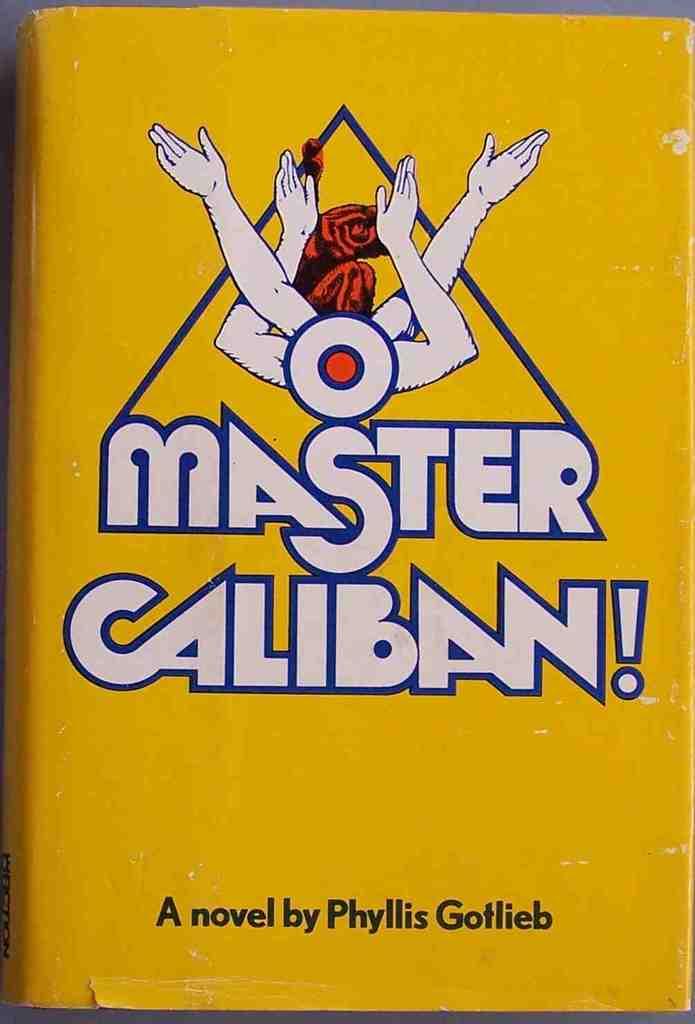Is this a novel?
Keep it short and to the point. Yes. 